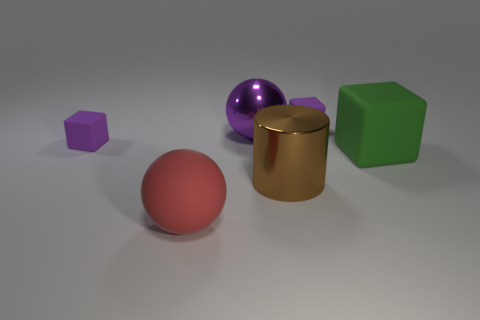Are there more small things that are to the left of the big green object than green rubber blocks?
Ensure brevity in your answer.  Yes. Is there a big purple thing made of the same material as the brown cylinder?
Your response must be concise. Yes. Do the tiny purple cube right of the large brown shiny object and the large sphere that is in front of the green block have the same material?
Your answer should be compact. Yes. Are there the same number of objects behind the big green matte thing and purple matte cubes on the right side of the metal cylinder?
Your answer should be compact. No. The block that is the same size as the brown cylinder is what color?
Offer a very short reply. Green. Is there a thing of the same color as the big shiny sphere?
Your answer should be very brief. Yes. What number of things are objects to the left of the large rubber cube or big green shiny cylinders?
Provide a short and direct response. 5. What number of other things are there of the same size as the green object?
Your answer should be compact. 3. What material is the big object that is behind the tiny purple cube that is in front of the tiny matte object right of the large cylinder?
Ensure brevity in your answer.  Metal. What number of balls are either brown rubber things or large brown metallic objects?
Your response must be concise. 0. 